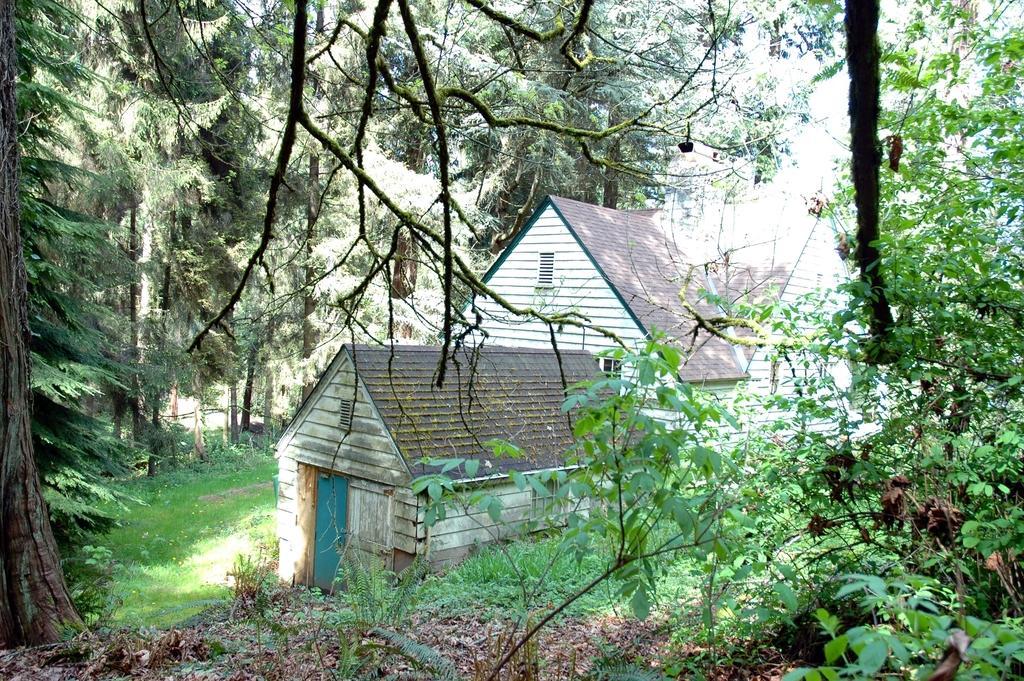In one or two sentences, can you explain what this image depicts? This image consists of a house. On the left and right, there are many trees. At the bottom, there is green grass and dried leaves. 